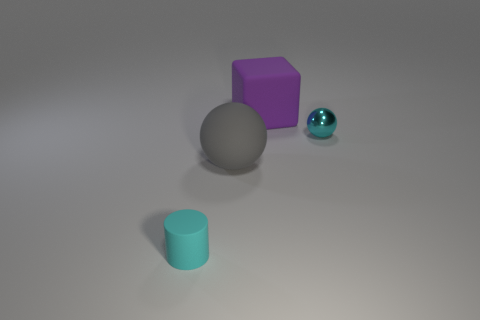Subtract 1 cylinders. How many cylinders are left? 0 Subtract all brown blocks. Subtract all brown spheres. How many blocks are left? 1 Subtract all red blocks. How many cyan balls are left? 1 Subtract all gray rubber objects. Subtract all large matte objects. How many objects are left? 1 Add 3 rubber balls. How many rubber balls are left? 4 Add 4 large purple rubber blocks. How many large purple rubber blocks exist? 5 Add 1 cyan rubber things. How many objects exist? 5 Subtract 1 cyan cylinders. How many objects are left? 3 Subtract all cubes. How many objects are left? 3 